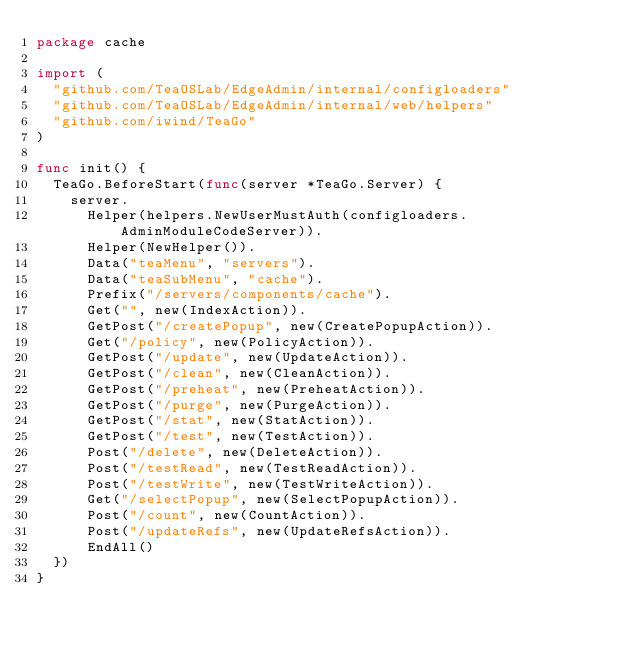Convert code to text. <code><loc_0><loc_0><loc_500><loc_500><_Go_>package cache

import (
	"github.com/TeaOSLab/EdgeAdmin/internal/configloaders"
	"github.com/TeaOSLab/EdgeAdmin/internal/web/helpers"
	"github.com/iwind/TeaGo"
)

func init() {
	TeaGo.BeforeStart(func(server *TeaGo.Server) {
		server.
			Helper(helpers.NewUserMustAuth(configloaders.AdminModuleCodeServer)).
			Helper(NewHelper()).
			Data("teaMenu", "servers").
			Data("teaSubMenu", "cache").
			Prefix("/servers/components/cache").
			Get("", new(IndexAction)).
			GetPost("/createPopup", new(CreatePopupAction)).
			Get("/policy", new(PolicyAction)).
			GetPost("/update", new(UpdateAction)).
			GetPost("/clean", new(CleanAction)).
			GetPost("/preheat", new(PreheatAction)).
			GetPost("/purge", new(PurgeAction)).
			GetPost("/stat", new(StatAction)).
			GetPost("/test", new(TestAction)).
			Post("/delete", new(DeleteAction)).
			Post("/testRead", new(TestReadAction)).
			Post("/testWrite", new(TestWriteAction)).
			Get("/selectPopup", new(SelectPopupAction)).
			Post("/count", new(CountAction)).
			Post("/updateRefs", new(UpdateRefsAction)).
			EndAll()
	})
}
</code> 